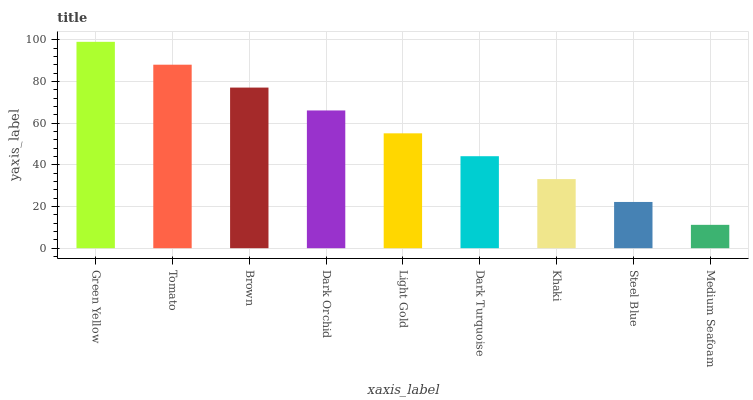Is Tomato the minimum?
Answer yes or no. No. Is Tomato the maximum?
Answer yes or no. No. Is Green Yellow greater than Tomato?
Answer yes or no. Yes. Is Tomato less than Green Yellow?
Answer yes or no. Yes. Is Tomato greater than Green Yellow?
Answer yes or no. No. Is Green Yellow less than Tomato?
Answer yes or no. No. Is Light Gold the high median?
Answer yes or no. Yes. Is Light Gold the low median?
Answer yes or no. Yes. Is Dark Turquoise the high median?
Answer yes or no. No. Is Green Yellow the low median?
Answer yes or no. No. 